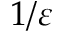<formula> <loc_0><loc_0><loc_500><loc_500>1 / \varepsilon</formula> 